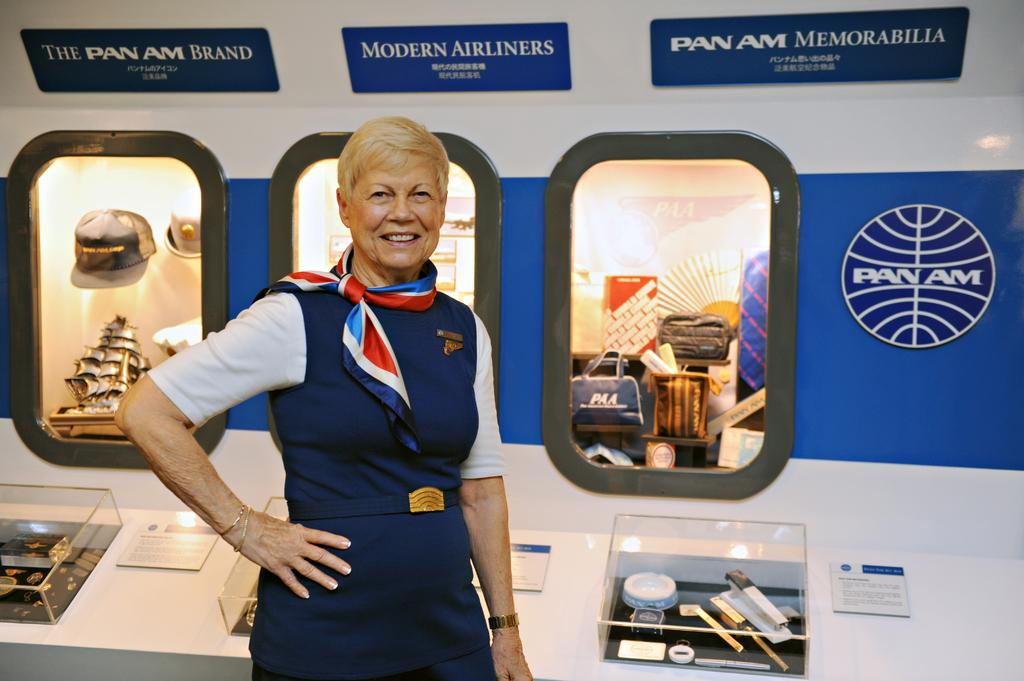<image>
Relay a brief, clear account of the picture shown. An older woman wearing Pan Am attire and standing by Pan Am memorabilia. 